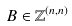<formula> <loc_0><loc_0><loc_500><loc_500>B \in \mathbb { Z } ^ { ( n , n ) }</formula> 